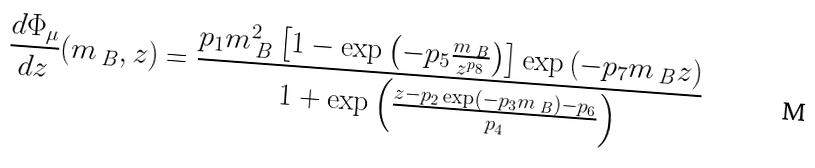<formula> <loc_0><loc_0><loc_500><loc_500>\frac { d \Phi _ { \mu } } { d z } ( m _ { \ B } , z ) = \frac { p _ { 1 } m _ { \ B } ^ { 2 } \left [ 1 - \exp \left ( - p _ { 5 } \frac { m _ { \ B } } { z ^ { p _ { 8 } } } \right ) \right ] \exp \left ( - p _ { 7 } m _ { \ B } z \right ) } { 1 + \exp \left ( \frac { z - p _ { 2 } \exp ( - p _ { 3 } m _ { \ B } ) - p _ { 6 } } { p _ { 4 } } \right ) }</formula> 